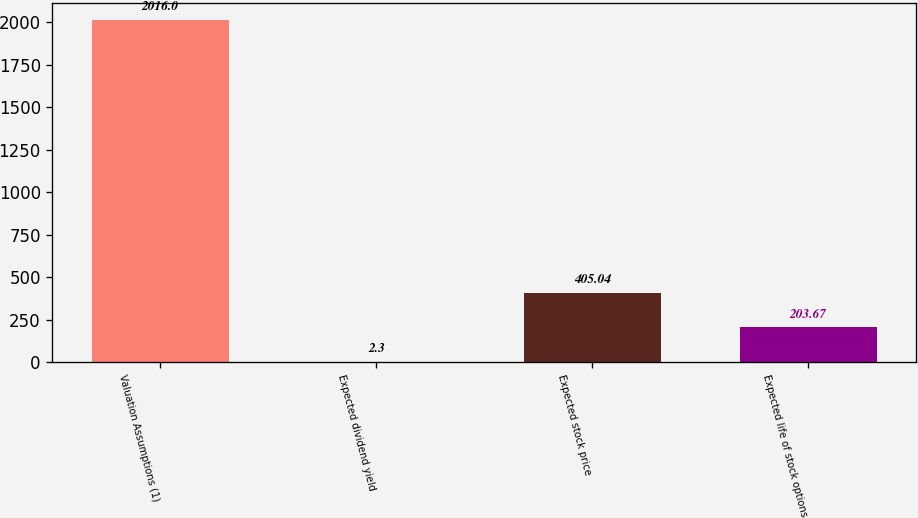Convert chart. <chart><loc_0><loc_0><loc_500><loc_500><bar_chart><fcel>Valuation Assumptions (1)<fcel>Expected dividend yield<fcel>Expected stock price<fcel>Expected life of stock options<nl><fcel>2016<fcel>2.3<fcel>405.04<fcel>203.67<nl></chart> 